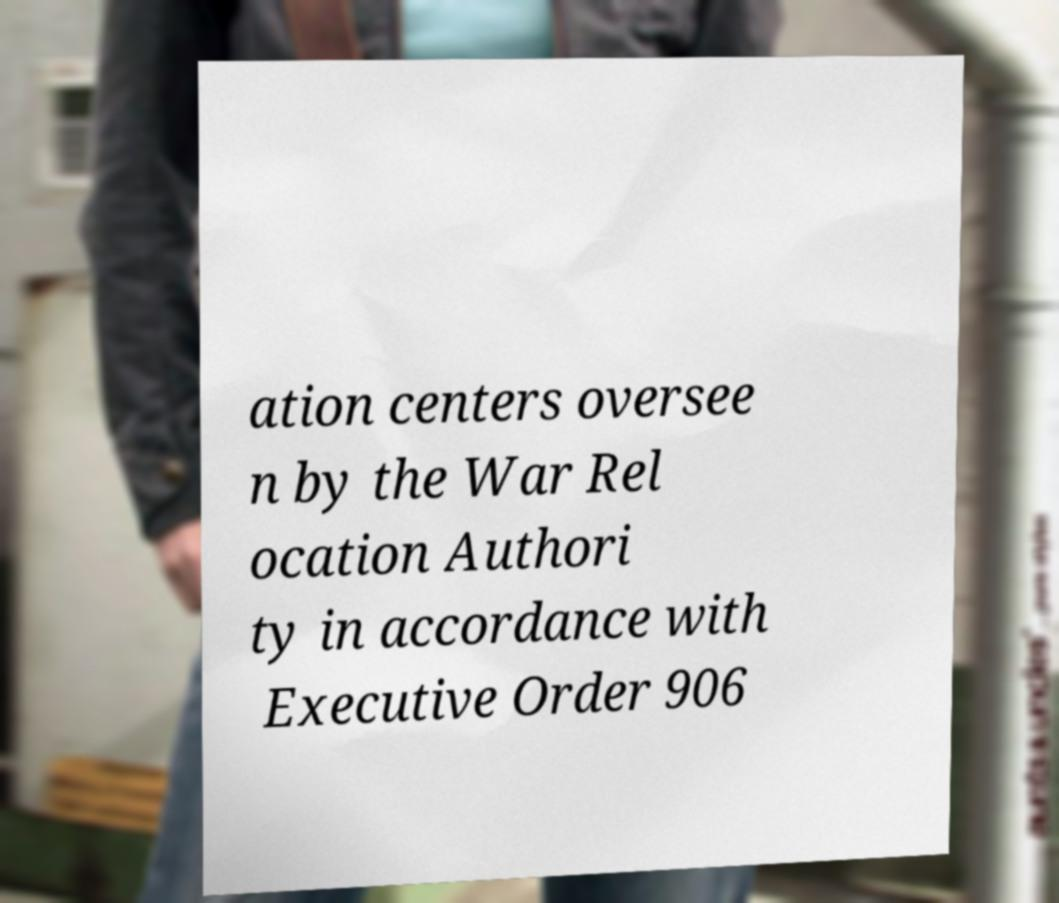Can you read and provide the text displayed in the image?This photo seems to have some interesting text. Can you extract and type it out for me? ation centers oversee n by the War Rel ocation Authori ty in accordance with Executive Order 906 